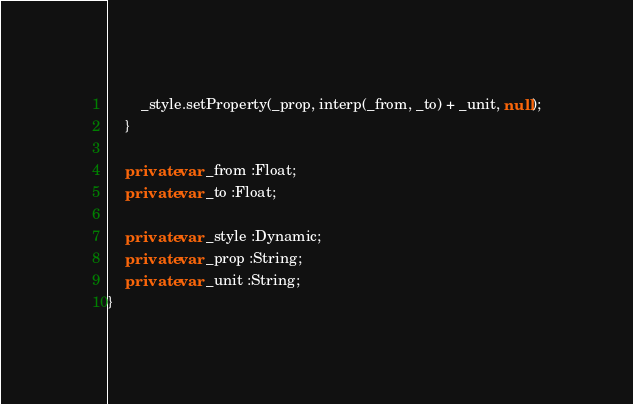Convert code to text. <code><loc_0><loc_0><loc_500><loc_500><_Haxe_>        _style.setProperty(_prop, interp(_from, _to) + _unit, null);
    }

    private var _from :Float;
    private var _to :Float;

    private var _style :Dynamic;
    private var _prop :String;
    private var _unit :String;
}
</code> 